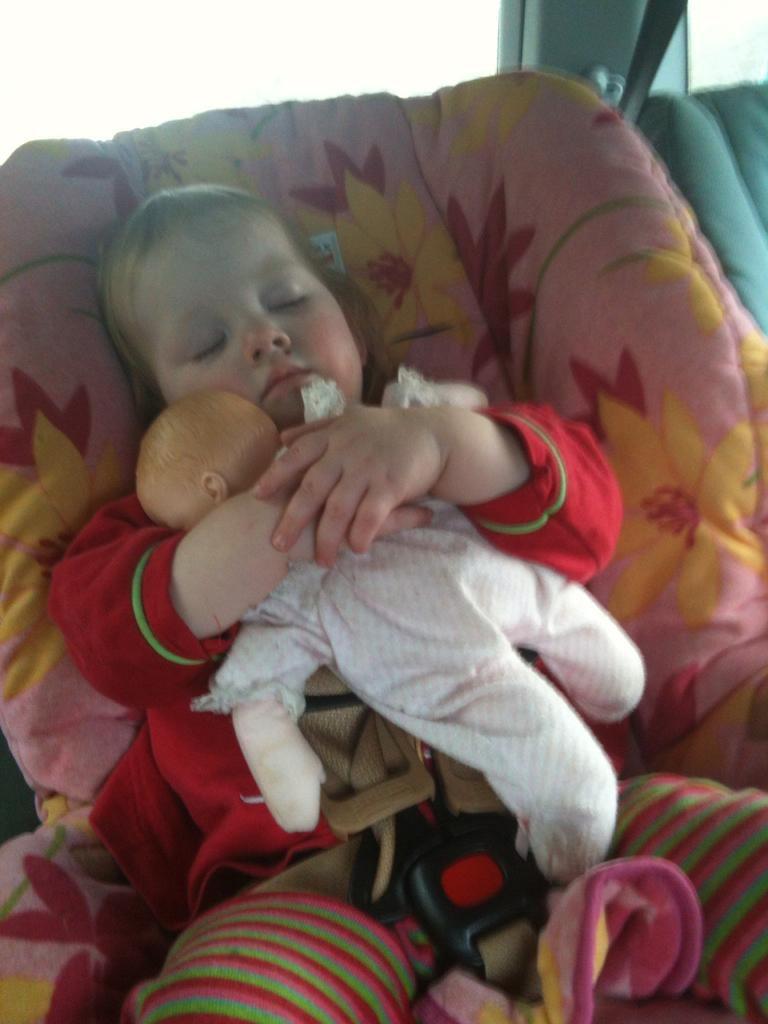What is the main subject of the image? There is a child in the image. What is the child doing in the image? The child is lying down. What is the child holding in its hands? The child is holding a doll in its hands. What can be seen in the background of the image? There are mirrors and a seat in the background of the image. What date is circled on the calendar in the image? There is no calendar present in the image. What type of neck accessory is the child wearing in the image? The child is not wearing any neck accessory in the image. 